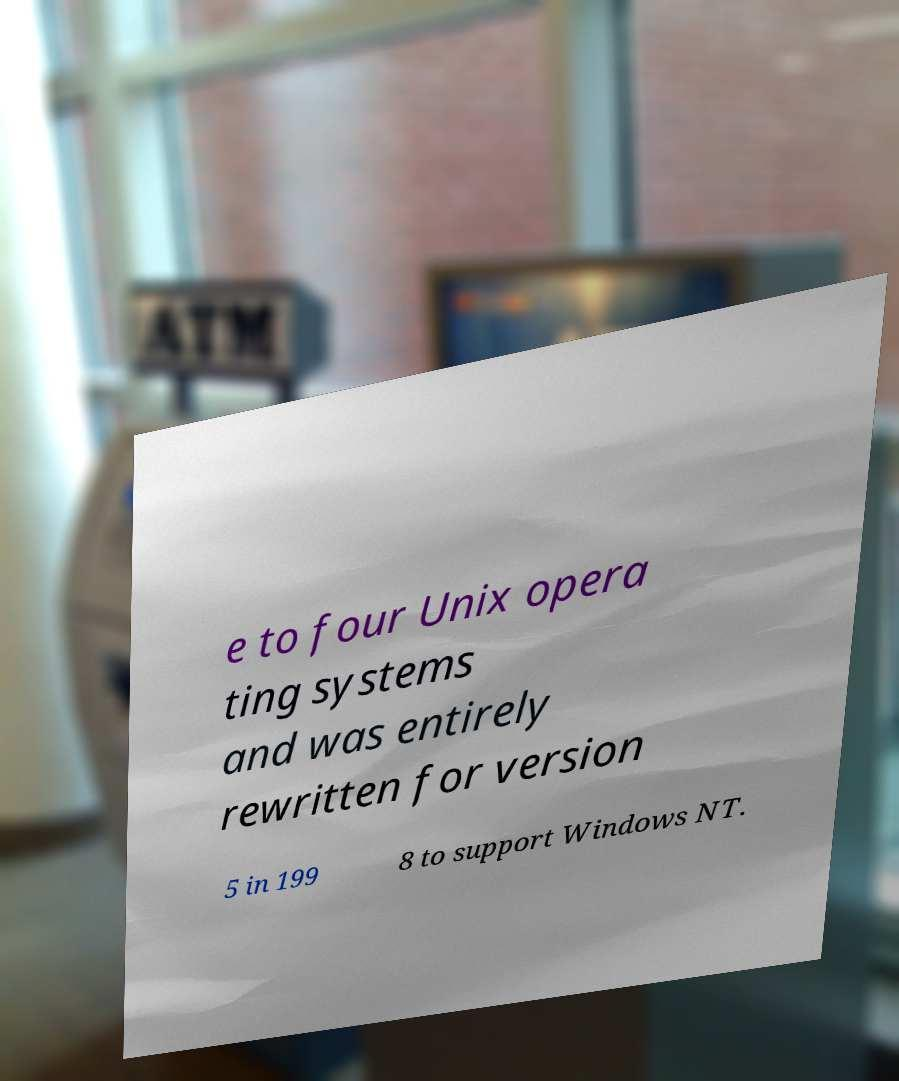For documentation purposes, I need the text within this image transcribed. Could you provide that? e to four Unix opera ting systems and was entirely rewritten for version 5 in 199 8 to support Windows NT. 